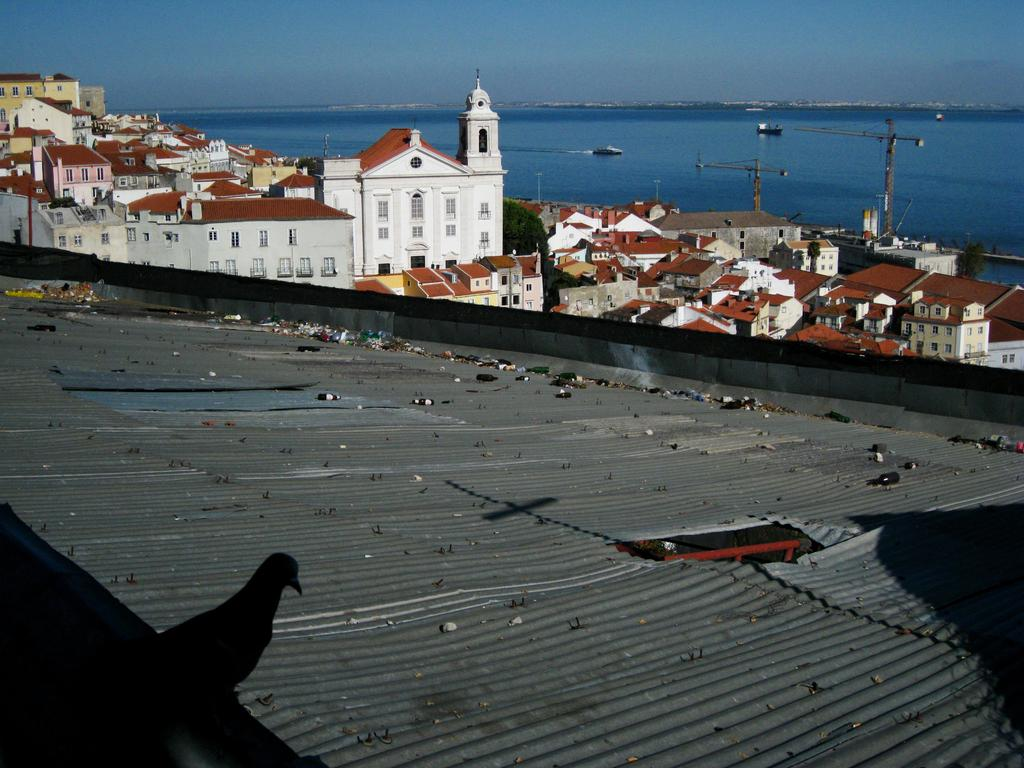What type of animal can be seen in the image? There is a bird in the image. What is located on the roof in the image? There are objects on the roof in the image. What can be seen in the background of the image? There are buildings, trees, poles, and boats on the water in the background of the image. What is visible at the top of the image? The sky is visible at the top of the image. What book is the bird reading in the image? There is no book or reading activity depicted in the image; it features a bird and various background elements. 